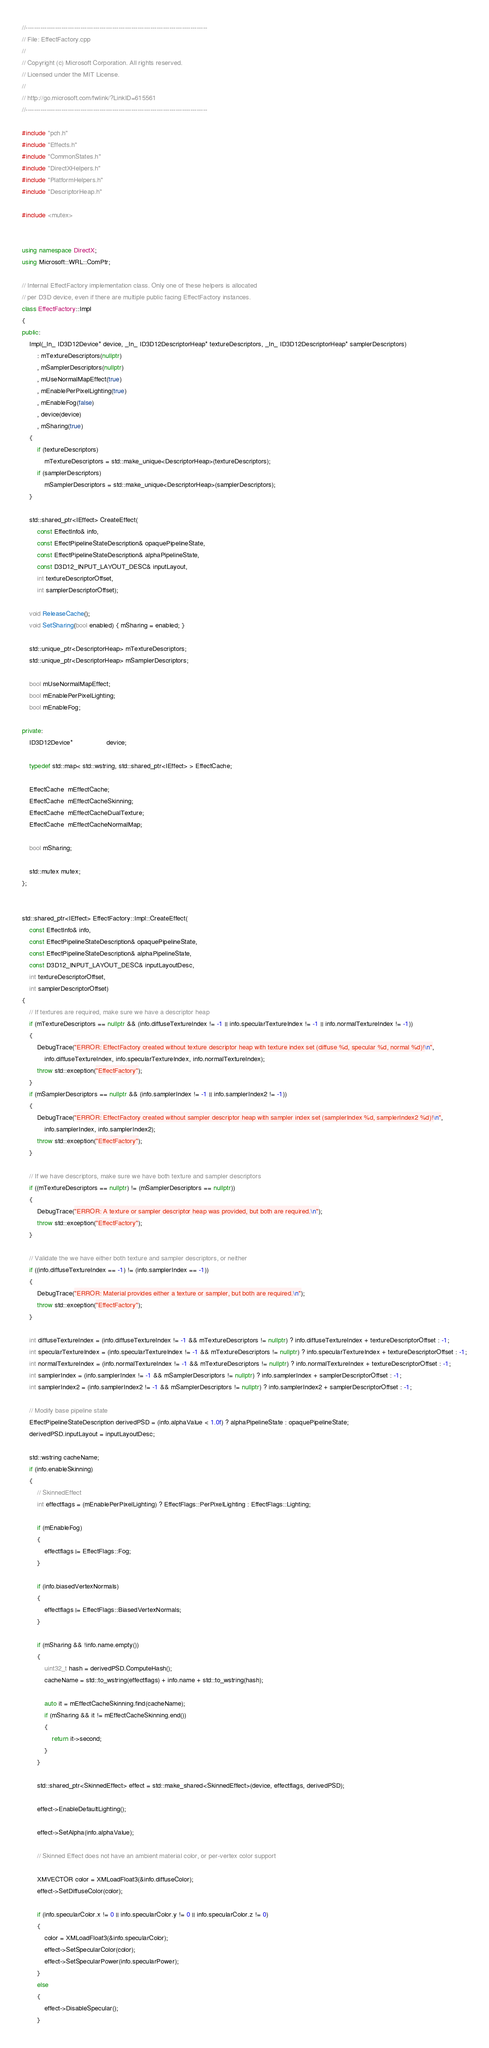<code> <loc_0><loc_0><loc_500><loc_500><_C++_>//--------------------------------------------------------------------------------------
// File: EffectFactory.cpp
//
// Copyright (c) Microsoft Corporation. All rights reserved.
// Licensed under the MIT License.
//
// http://go.microsoft.com/fwlink/?LinkID=615561
//--------------------------------------------------------------------------------------

#include "pch.h"
#include "Effects.h"
#include "CommonStates.h"
#include "DirectXHelpers.h"
#include "PlatformHelpers.h"
#include "DescriptorHeap.h"

#include <mutex>


using namespace DirectX;
using Microsoft::WRL::ComPtr;

// Internal EffectFactory implementation class. Only one of these helpers is allocated
// per D3D device, even if there are multiple public facing EffectFactory instances.
class EffectFactory::Impl
{
public:
    Impl(_In_ ID3D12Device* device, _In_ ID3D12DescriptorHeap* textureDescriptors, _In_ ID3D12DescriptorHeap* samplerDescriptors)
        : mTextureDescriptors(nullptr)
        , mSamplerDescriptors(nullptr)
        , mUseNormalMapEffect(true)
        , mEnablePerPixelLighting(true)
        , mEnableFog(false)
        , device(device)
        , mSharing(true)
    { 
        if (textureDescriptors)
            mTextureDescriptors = std::make_unique<DescriptorHeap>(textureDescriptors);
        if (samplerDescriptors)
            mSamplerDescriptors = std::make_unique<DescriptorHeap>(samplerDescriptors);
    }

    std::shared_ptr<IEffect> CreateEffect(
        const EffectInfo& info,
        const EffectPipelineStateDescription& opaquePipelineState,
        const EffectPipelineStateDescription& alphaPipelineState,
        const D3D12_INPUT_LAYOUT_DESC& inputLayout,
        int textureDescriptorOffset,
        int samplerDescriptorOffset);

    void ReleaseCache();
    void SetSharing(bool enabled) { mSharing = enabled; }

    std::unique_ptr<DescriptorHeap> mTextureDescriptors;
    std::unique_ptr<DescriptorHeap> mSamplerDescriptors;

    bool mUseNormalMapEffect;
    bool mEnablePerPixelLighting;
    bool mEnableFog;

private:
    ID3D12Device*                  device;

    typedef std::map< std::wstring, std::shared_ptr<IEffect> > EffectCache;

    EffectCache  mEffectCache;
    EffectCache  mEffectCacheSkinning;
    EffectCache  mEffectCacheDualTexture;
    EffectCache  mEffectCacheNormalMap;

    bool mSharing;

    std::mutex mutex;
};


std::shared_ptr<IEffect> EffectFactory::Impl::CreateEffect(
    const EffectInfo& info,
    const EffectPipelineStateDescription& opaquePipelineState,
    const EffectPipelineStateDescription& alphaPipelineState,
    const D3D12_INPUT_LAYOUT_DESC& inputLayoutDesc,
    int textureDescriptorOffset,
    int samplerDescriptorOffset)
{
    // If textures are required, make sure we have a descriptor heap
    if (mTextureDescriptors == nullptr && (info.diffuseTextureIndex != -1 || info.specularTextureIndex != -1 || info.normalTextureIndex != -1))
    {
        DebugTrace("ERROR: EffectFactory created without texture descriptor heap with texture index set (diffuse %d, specular %d, normal %d)!\n",
            info.diffuseTextureIndex, info.specularTextureIndex, info.normalTextureIndex);
        throw std::exception("EffectFactory");
    }
    if (mSamplerDescriptors == nullptr && (info.samplerIndex != -1 || info.samplerIndex2 != -1))
    {
        DebugTrace("ERROR: EffectFactory created without sampler descriptor heap with sampler index set (samplerIndex %d, samplerIndex2 %d)!\n",
            info.samplerIndex, info.samplerIndex2);
        throw std::exception("EffectFactory");
    }

    // If we have descriptors, make sure we have both texture and sampler descriptors
    if ((mTextureDescriptors == nullptr) != (mSamplerDescriptors == nullptr))
    {
        DebugTrace("ERROR: A texture or sampler descriptor heap was provided, but both are required.\n");
        throw std::exception("EffectFactory");
    }

    // Validate the we have either both texture and sampler descriptors, or neither
    if ((info.diffuseTextureIndex == -1) != (info.samplerIndex == -1))
    {
        DebugTrace("ERROR: Material provides either a texture or sampler, but both are required.\n");
        throw std::exception("EffectFactory");
    }

    int diffuseTextureIndex = (info.diffuseTextureIndex != -1 && mTextureDescriptors != nullptr) ? info.diffuseTextureIndex + textureDescriptorOffset : -1;
    int specularTextureIndex = (info.specularTextureIndex != -1 && mTextureDescriptors != nullptr) ? info.specularTextureIndex + textureDescriptorOffset : -1;
    int normalTextureIndex = (info.normalTextureIndex != -1 && mTextureDescriptors != nullptr) ? info.normalTextureIndex + textureDescriptorOffset : -1;
    int samplerIndex = (info.samplerIndex != -1 && mSamplerDescriptors != nullptr) ? info.samplerIndex + samplerDescriptorOffset : -1;
    int samplerIndex2 = (info.samplerIndex2 != -1 && mSamplerDescriptors != nullptr) ? info.samplerIndex2 + samplerDescriptorOffset : -1;

    // Modify base pipeline state
    EffectPipelineStateDescription derivedPSD = (info.alphaValue < 1.0f) ? alphaPipelineState : opaquePipelineState;
    derivedPSD.inputLayout = inputLayoutDesc;

    std::wstring cacheName;
    if (info.enableSkinning)
    {
        // SkinnedEffect
        int effectflags = (mEnablePerPixelLighting) ? EffectFlags::PerPixelLighting : EffectFlags::Lighting;

        if (mEnableFog)
        {
            effectflags |= EffectFlags::Fog;
        }

        if (info.biasedVertexNormals)
        {
            effectflags |= EffectFlags::BiasedVertexNormals;
        }

        if (mSharing && !info.name.empty())
        {
            uint32_t hash = derivedPSD.ComputeHash();
            cacheName = std::to_wstring(effectflags) + info.name + std::to_wstring(hash);

            auto it = mEffectCacheSkinning.find(cacheName);
            if (mSharing && it != mEffectCacheSkinning.end())
            {
                return it->second;
            }
        }

        std::shared_ptr<SkinnedEffect> effect = std::make_shared<SkinnedEffect>(device, effectflags, derivedPSD);

        effect->EnableDefaultLighting();

        effect->SetAlpha(info.alphaValue);

        // Skinned Effect does not have an ambient material color, or per-vertex color support

        XMVECTOR color = XMLoadFloat3(&info.diffuseColor);
        effect->SetDiffuseColor(color);

        if (info.specularColor.x != 0 || info.specularColor.y != 0 || info.specularColor.z != 0)
        {
            color = XMLoadFloat3(&info.specularColor);
            effect->SetSpecularColor(color);
            effect->SetSpecularPower(info.specularPower);
        }
        else
        {
            effect->DisableSpecular();
        }
</code> 